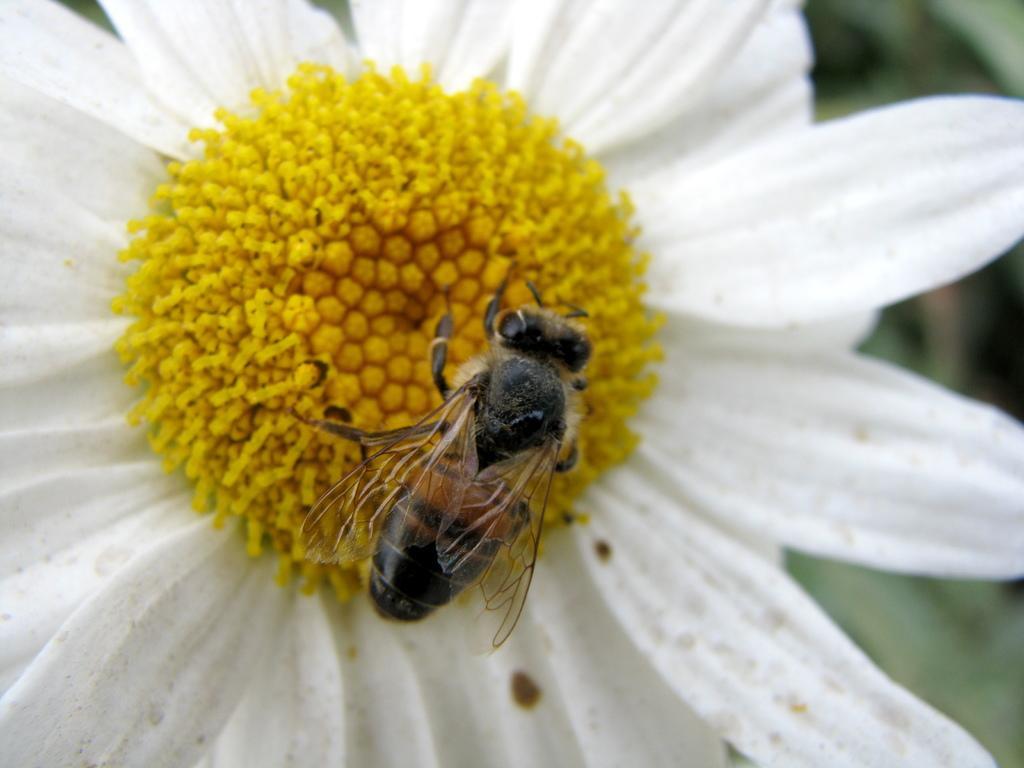How would you summarize this image in a sentence or two? In this picture I can see there is a bee sitting on the flower and the flower has white petals. The bee has a head, wings, body and the backdrop is blurred. 